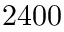<formula> <loc_0><loc_0><loc_500><loc_500>2 4 0 0</formula> 